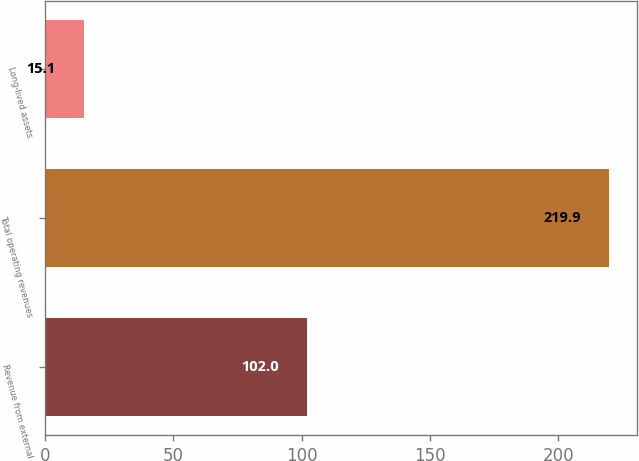Convert chart. <chart><loc_0><loc_0><loc_500><loc_500><bar_chart><fcel>Revenue from external<fcel>Total operating revenues<fcel>Long-lived assets<nl><fcel>102<fcel>219.9<fcel>15.1<nl></chart> 